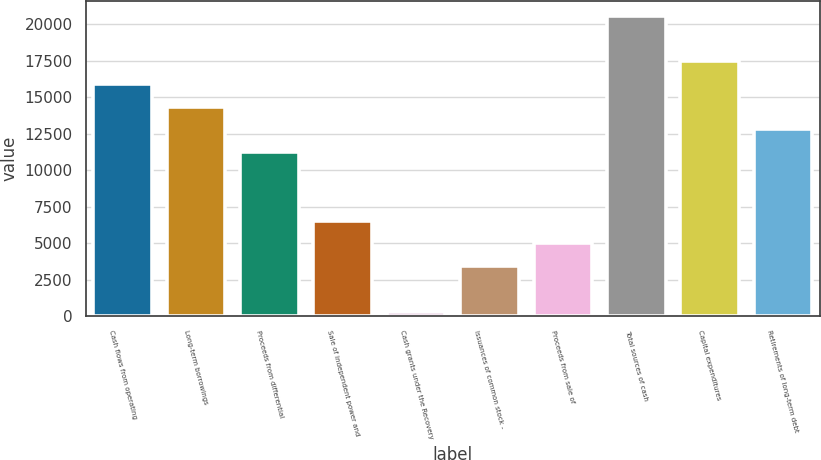<chart> <loc_0><loc_0><loc_500><loc_500><bar_chart><fcel>Cash flows from operating<fcel>Long-term borrowings<fcel>Proceeds from differential<fcel>Sale of independent power and<fcel>Cash grants under the Recovery<fcel>Issuances of common stock -<fcel>Proceeds from sale of<fcel>Total sources of cash<fcel>Capital expenditures<fcel>Retirements of long-term debt<nl><fcel>15905<fcel>14348<fcel>11234<fcel>6563<fcel>335<fcel>3449<fcel>5006<fcel>20576<fcel>17462<fcel>12791<nl></chart> 